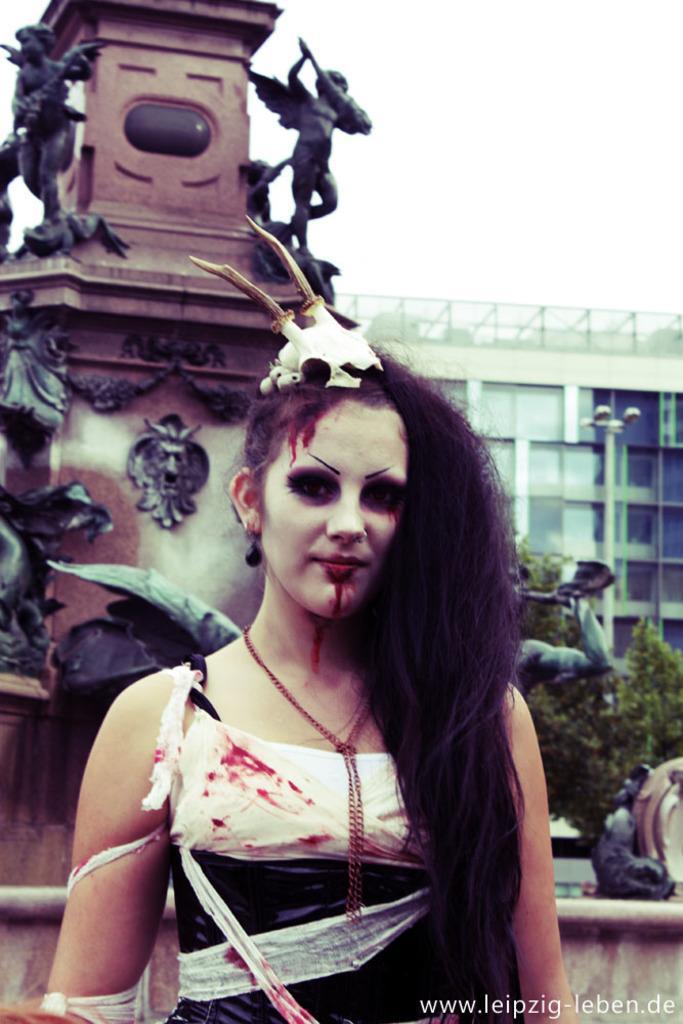In one or two sentences, can you explain what this image depicts? In this image we can see a woman. In the background we can see statues, leaves, pole, building, and sky. At the bottom of the image we can see something is written on it. 